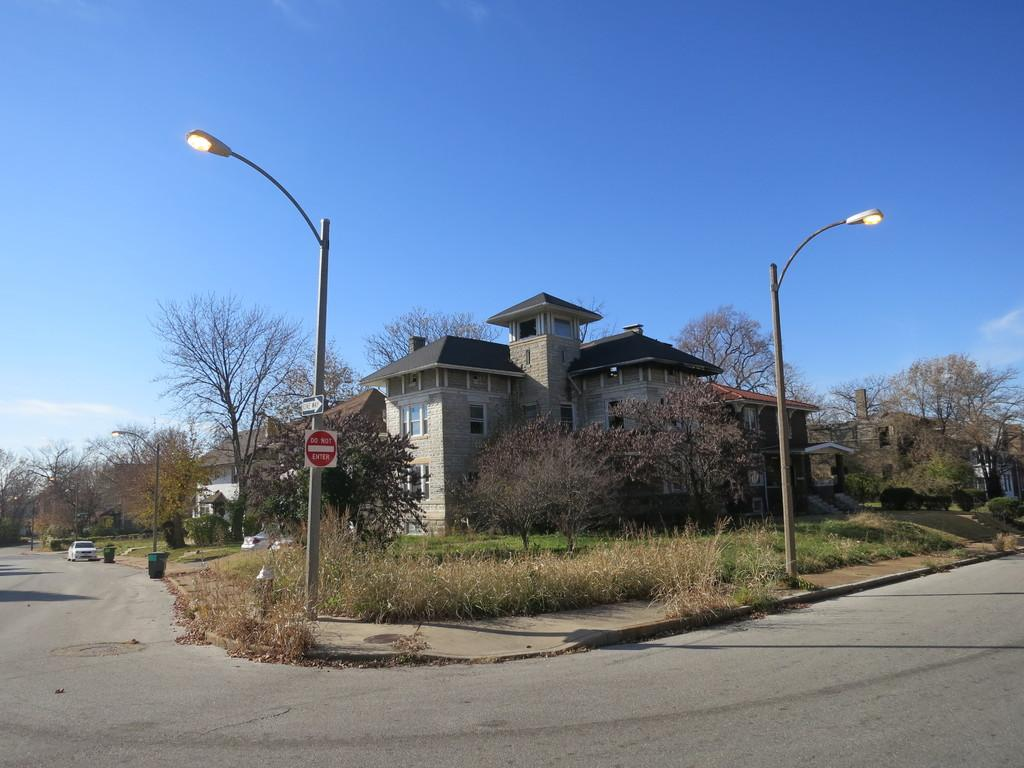<image>
Share a concise interpretation of the image provided. A do not enter sign is on the corner in front of a large house. 